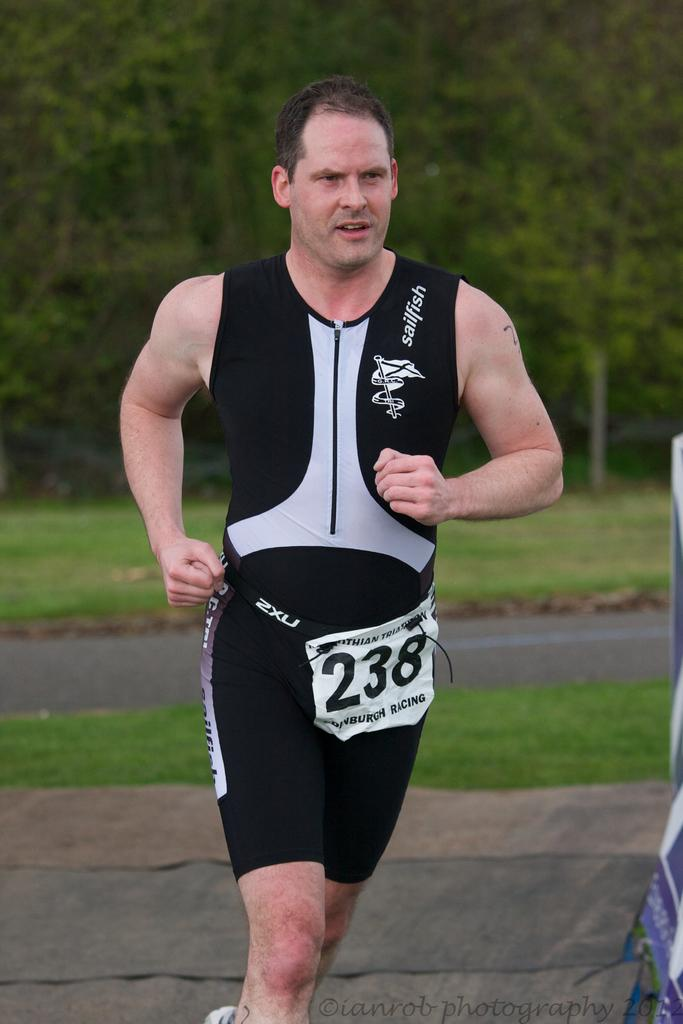<image>
Relay a brief, clear account of the picture shown. Runner #238 in a triathalon wears a black sailfish jersey. 